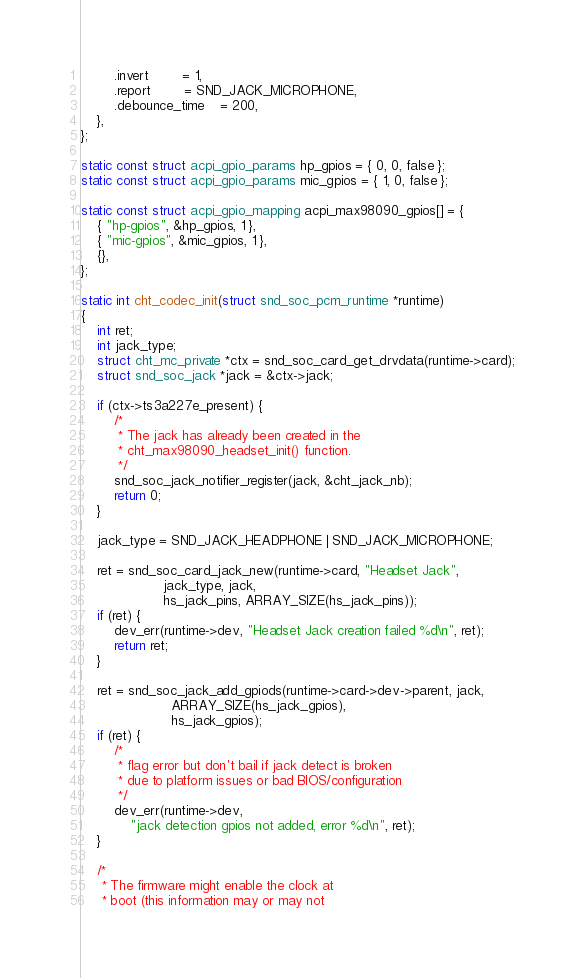Convert code to text. <code><loc_0><loc_0><loc_500><loc_500><_C_>		.invert		= 1,
		.report		= SND_JACK_MICROPHONE,
		.debounce_time	= 200,
	},
};

static const struct acpi_gpio_params hp_gpios = { 0, 0, false };
static const struct acpi_gpio_params mic_gpios = { 1, 0, false };

static const struct acpi_gpio_mapping acpi_max98090_gpios[] = {
	{ "hp-gpios", &hp_gpios, 1 },
	{ "mic-gpios", &mic_gpios, 1 },
	{},
};

static int cht_codec_init(struct snd_soc_pcm_runtime *runtime)
{
	int ret;
	int jack_type;
	struct cht_mc_private *ctx = snd_soc_card_get_drvdata(runtime->card);
	struct snd_soc_jack *jack = &ctx->jack;

	if (ctx->ts3a227e_present) {
		/*
		 * The jack has already been created in the
		 * cht_max98090_headset_init() function.
		 */
		snd_soc_jack_notifier_register(jack, &cht_jack_nb);
		return 0;
	}

	jack_type = SND_JACK_HEADPHONE | SND_JACK_MICROPHONE;

	ret = snd_soc_card_jack_new(runtime->card, "Headset Jack",
				    jack_type, jack,
				    hs_jack_pins, ARRAY_SIZE(hs_jack_pins));
	if (ret) {
		dev_err(runtime->dev, "Headset Jack creation failed %d\n", ret);
		return ret;
	}

	ret = snd_soc_jack_add_gpiods(runtime->card->dev->parent, jack,
				      ARRAY_SIZE(hs_jack_gpios),
				      hs_jack_gpios);
	if (ret) {
		/*
		 * flag error but don't bail if jack detect is broken
		 * due to platform issues or bad BIOS/configuration
		 */
		dev_err(runtime->dev,
			"jack detection gpios not added, error %d\n", ret);
	}

	/*
	 * The firmware might enable the clock at
	 * boot (this information may or may not</code> 